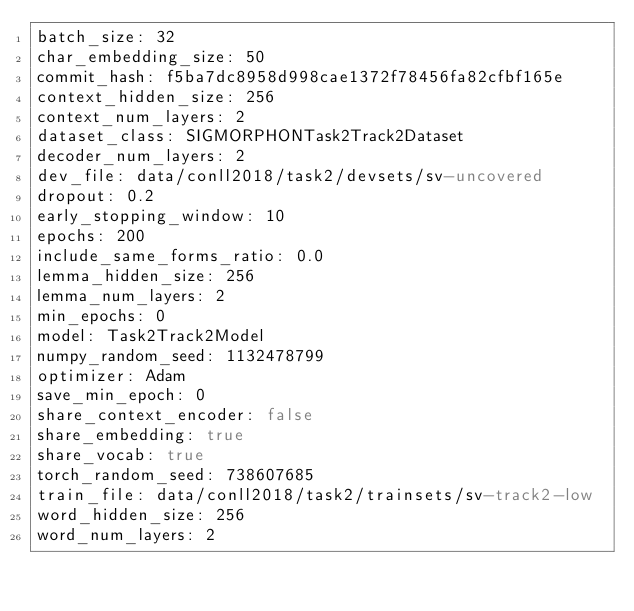<code> <loc_0><loc_0><loc_500><loc_500><_YAML_>batch_size: 32
char_embedding_size: 50
commit_hash: f5ba7dc8958d998cae1372f78456fa82cfbf165e
context_hidden_size: 256
context_num_layers: 2
dataset_class: SIGMORPHONTask2Track2Dataset
decoder_num_layers: 2
dev_file: data/conll2018/task2/devsets/sv-uncovered
dropout: 0.2
early_stopping_window: 10
epochs: 200
include_same_forms_ratio: 0.0
lemma_hidden_size: 256
lemma_num_layers: 2
min_epochs: 0
model: Task2Track2Model
numpy_random_seed: 1132478799
optimizer: Adam
save_min_epoch: 0
share_context_encoder: false
share_embedding: true
share_vocab: true
torch_random_seed: 738607685
train_file: data/conll2018/task2/trainsets/sv-track2-low
word_hidden_size: 256
word_num_layers: 2
</code> 